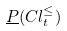<formula> <loc_0><loc_0><loc_500><loc_500>\underline { P } ( C l _ { t } ^ { \leq } )</formula> 